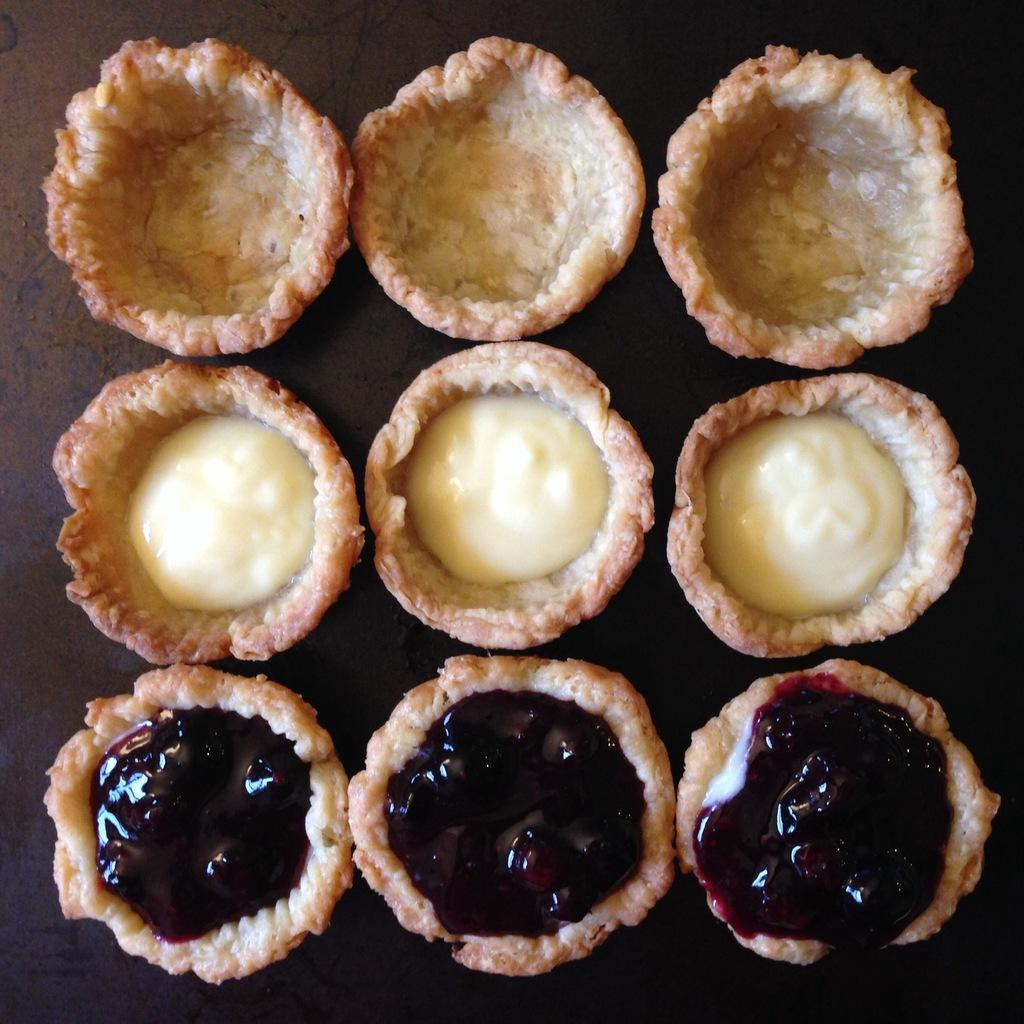What is located in the center of the image? There is a table in the center of the image. What can be found on the table? There are food items on the table. What type of wax can be seen melting on the table in the image? There is no wax present in the image; it only features a table and food items. 